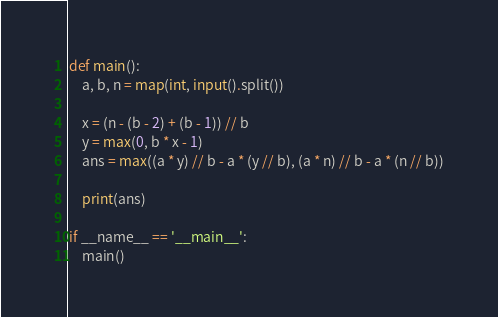Convert code to text. <code><loc_0><loc_0><loc_500><loc_500><_Python_>def main():
    a, b, n = map(int, input().split())

    x = (n - (b - 2) + (b - 1)) // b
    y = max(0, b * x - 1)
    ans = max((a * y) // b - a * (y // b), (a * n) // b - a * (n // b))

    print(ans)

if __name__ == '__main__':
    main()
</code> 